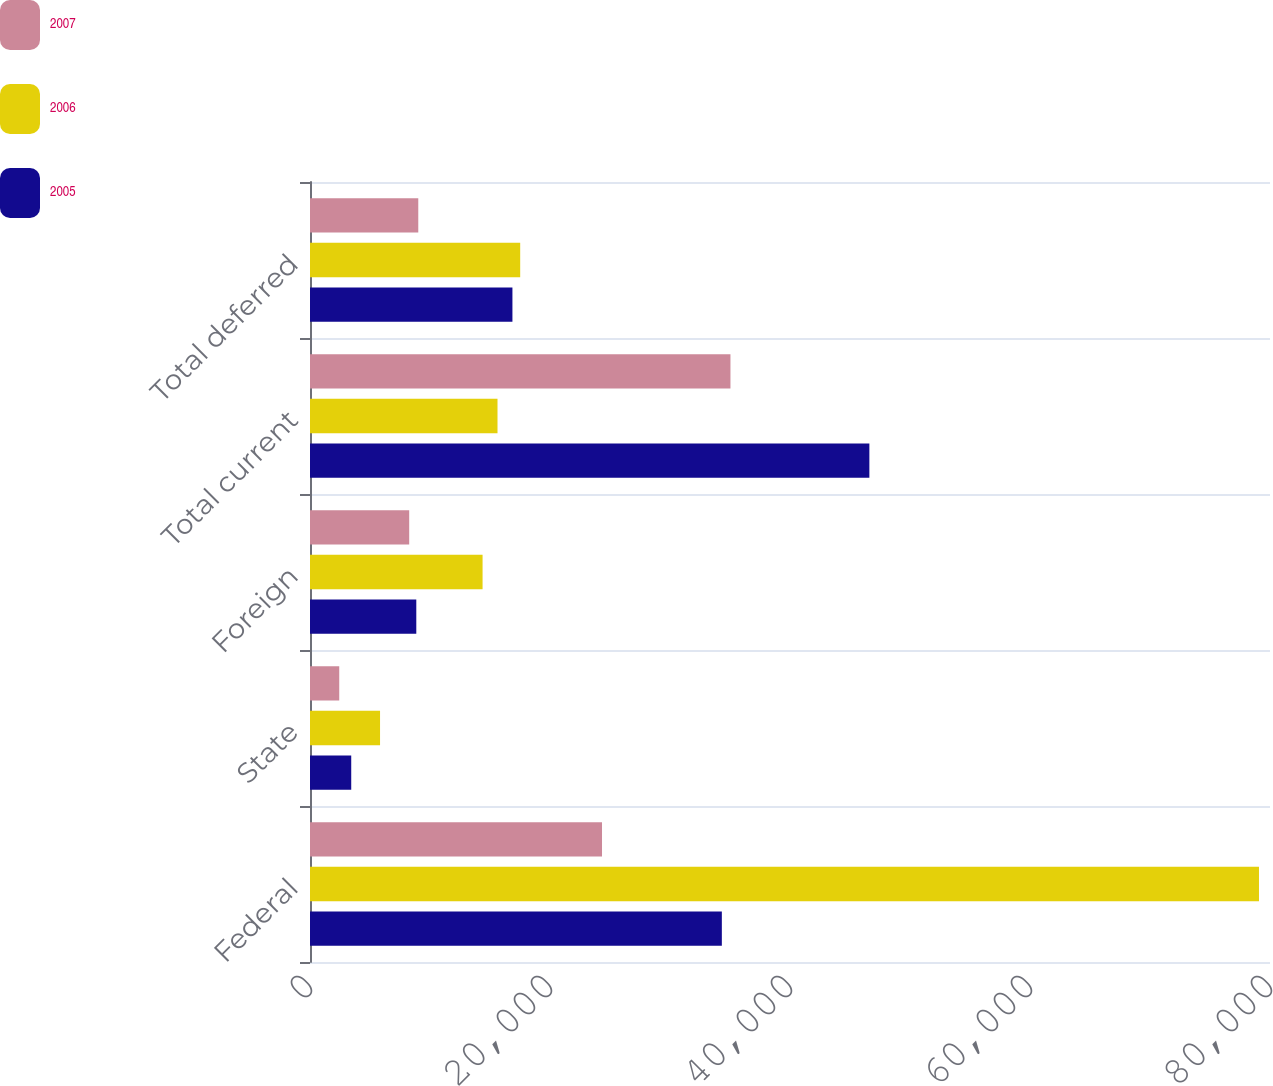Convert chart to OTSL. <chart><loc_0><loc_0><loc_500><loc_500><stacked_bar_chart><ecel><fcel>Federal<fcel>State<fcel>Foreign<fcel>Total current<fcel>Total deferred<nl><fcel>2007<fcel>24334<fcel>2437<fcel>8267<fcel>35038<fcel>9023<nl><fcel>2006<fcel>79082<fcel>5837<fcel>14381<fcel>15625<fcel>17516<nl><fcel>2005<fcel>34320<fcel>3436<fcel>8858<fcel>46614<fcel>16869<nl></chart> 